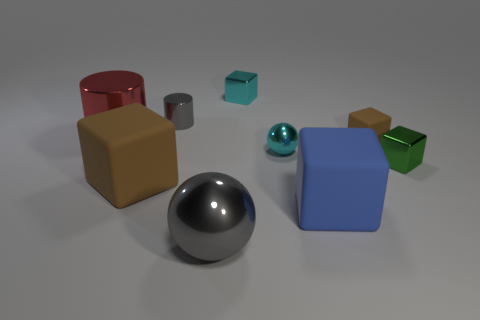Does the brown thing in front of the small green thing have the same material as the brown cube behind the tiny green thing?
Make the answer very short. Yes. The gray shiny object that is in front of the brown thing that is behind the green object is what shape?
Your answer should be very brief. Sphere. Is there any other thing of the same color as the small rubber object?
Offer a terse response. Yes. There is a metal cube to the left of the small metal cube that is in front of the red metal object; are there any small blocks in front of it?
Provide a short and direct response. Yes. There is a metal cylinder that is behind the red cylinder; is it the same color as the sphere that is behind the green shiny object?
Provide a succinct answer. No. There is a green cube that is the same size as the cyan metallic ball; what is its material?
Keep it short and to the point. Metal. There is a brown cube to the right of the gray object that is in front of the metal block in front of the tiny matte block; what is its size?
Your answer should be compact. Small. What number of other objects are there of the same material as the big brown thing?
Offer a terse response. 2. What is the size of the blue matte cube that is to the right of the tiny gray cylinder?
Offer a very short reply. Large. How many small objects are behind the large cylinder and right of the small brown object?
Your answer should be very brief. 0. 